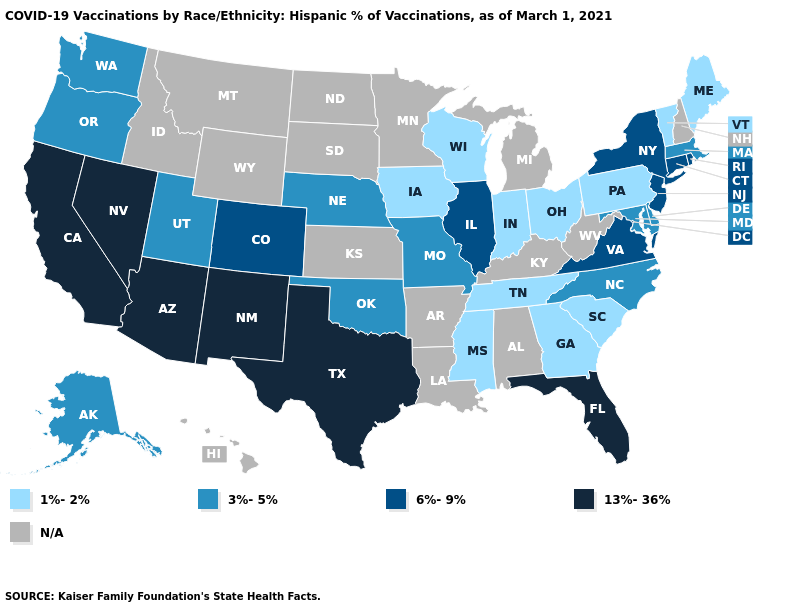How many symbols are there in the legend?
Keep it brief. 5. What is the lowest value in the West?
Answer briefly. 3%-5%. Does the first symbol in the legend represent the smallest category?
Give a very brief answer. Yes. Name the states that have a value in the range 1%-2%?
Keep it brief. Georgia, Indiana, Iowa, Maine, Mississippi, Ohio, Pennsylvania, South Carolina, Tennessee, Vermont, Wisconsin. Does Texas have the lowest value in the South?
Give a very brief answer. No. Name the states that have a value in the range 1%-2%?
Be succinct. Georgia, Indiana, Iowa, Maine, Mississippi, Ohio, Pennsylvania, South Carolina, Tennessee, Vermont, Wisconsin. What is the value of Rhode Island?
Be succinct. 6%-9%. Name the states that have a value in the range 1%-2%?
Give a very brief answer. Georgia, Indiana, Iowa, Maine, Mississippi, Ohio, Pennsylvania, South Carolina, Tennessee, Vermont, Wisconsin. Does Massachusetts have the highest value in the Northeast?
Give a very brief answer. No. Name the states that have a value in the range 1%-2%?
Keep it brief. Georgia, Indiana, Iowa, Maine, Mississippi, Ohio, Pennsylvania, South Carolina, Tennessee, Vermont, Wisconsin. Does Rhode Island have the highest value in the Northeast?
Answer briefly. Yes. Name the states that have a value in the range 1%-2%?
Give a very brief answer. Georgia, Indiana, Iowa, Maine, Mississippi, Ohio, Pennsylvania, South Carolina, Tennessee, Vermont, Wisconsin. Name the states that have a value in the range 13%-36%?
Keep it brief. Arizona, California, Florida, Nevada, New Mexico, Texas. What is the value of Utah?
Be succinct. 3%-5%. 